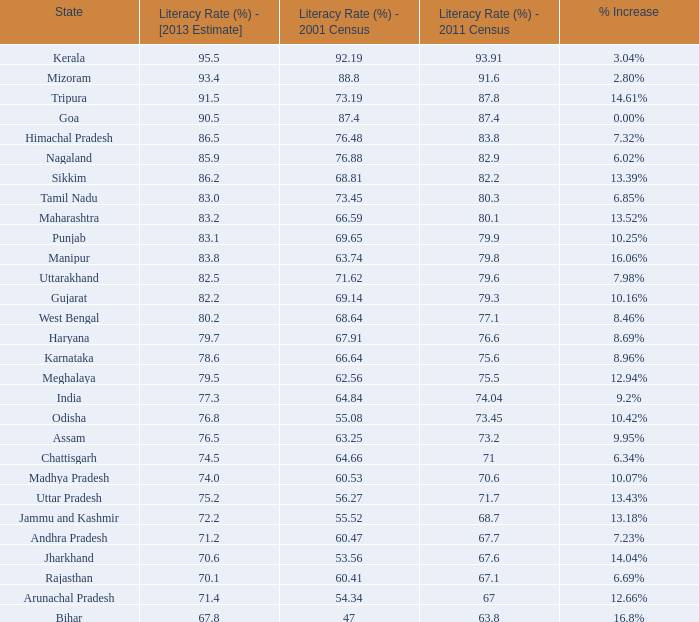What is the typical rise in literacy for the states that had a rate greater than 7 10.42%. 